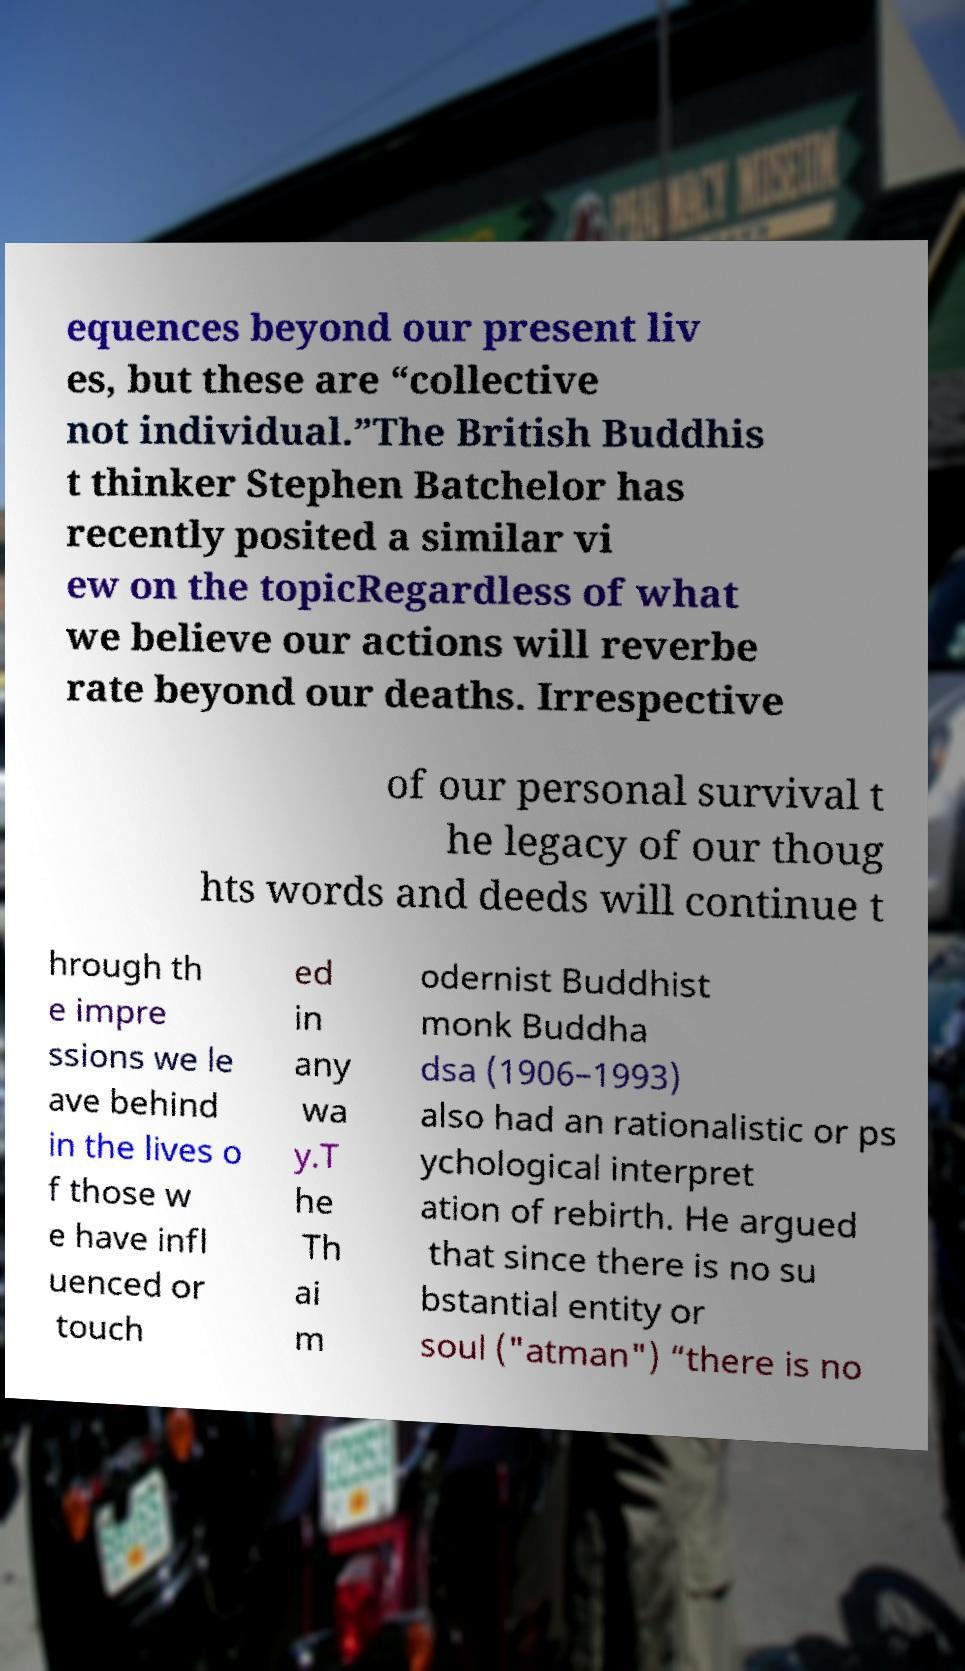Could you extract and type out the text from this image? equences beyond our present liv es, but these are “collective not individual.”The British Buddhis t thinker Stephen Batchelor has recently posited a similar vi ew on the topicRegardless of what we believe our actions will reverbe rate beyond our deaths. Irrespective of our personal survival t he legacy of our thoug hts words and deeds will continue t hrough th e impre ssions we le ave behind in the lives o f those w e have infl uenced or touch ed in any wa y.T he Th ai m odernist Buddhist monk Buddha dsa (1906–1993) also had an rationalistic or ps ychological interpret ation of rebirth. He argued that since there is no su bstantial entity or soul ("atman") “there is no 